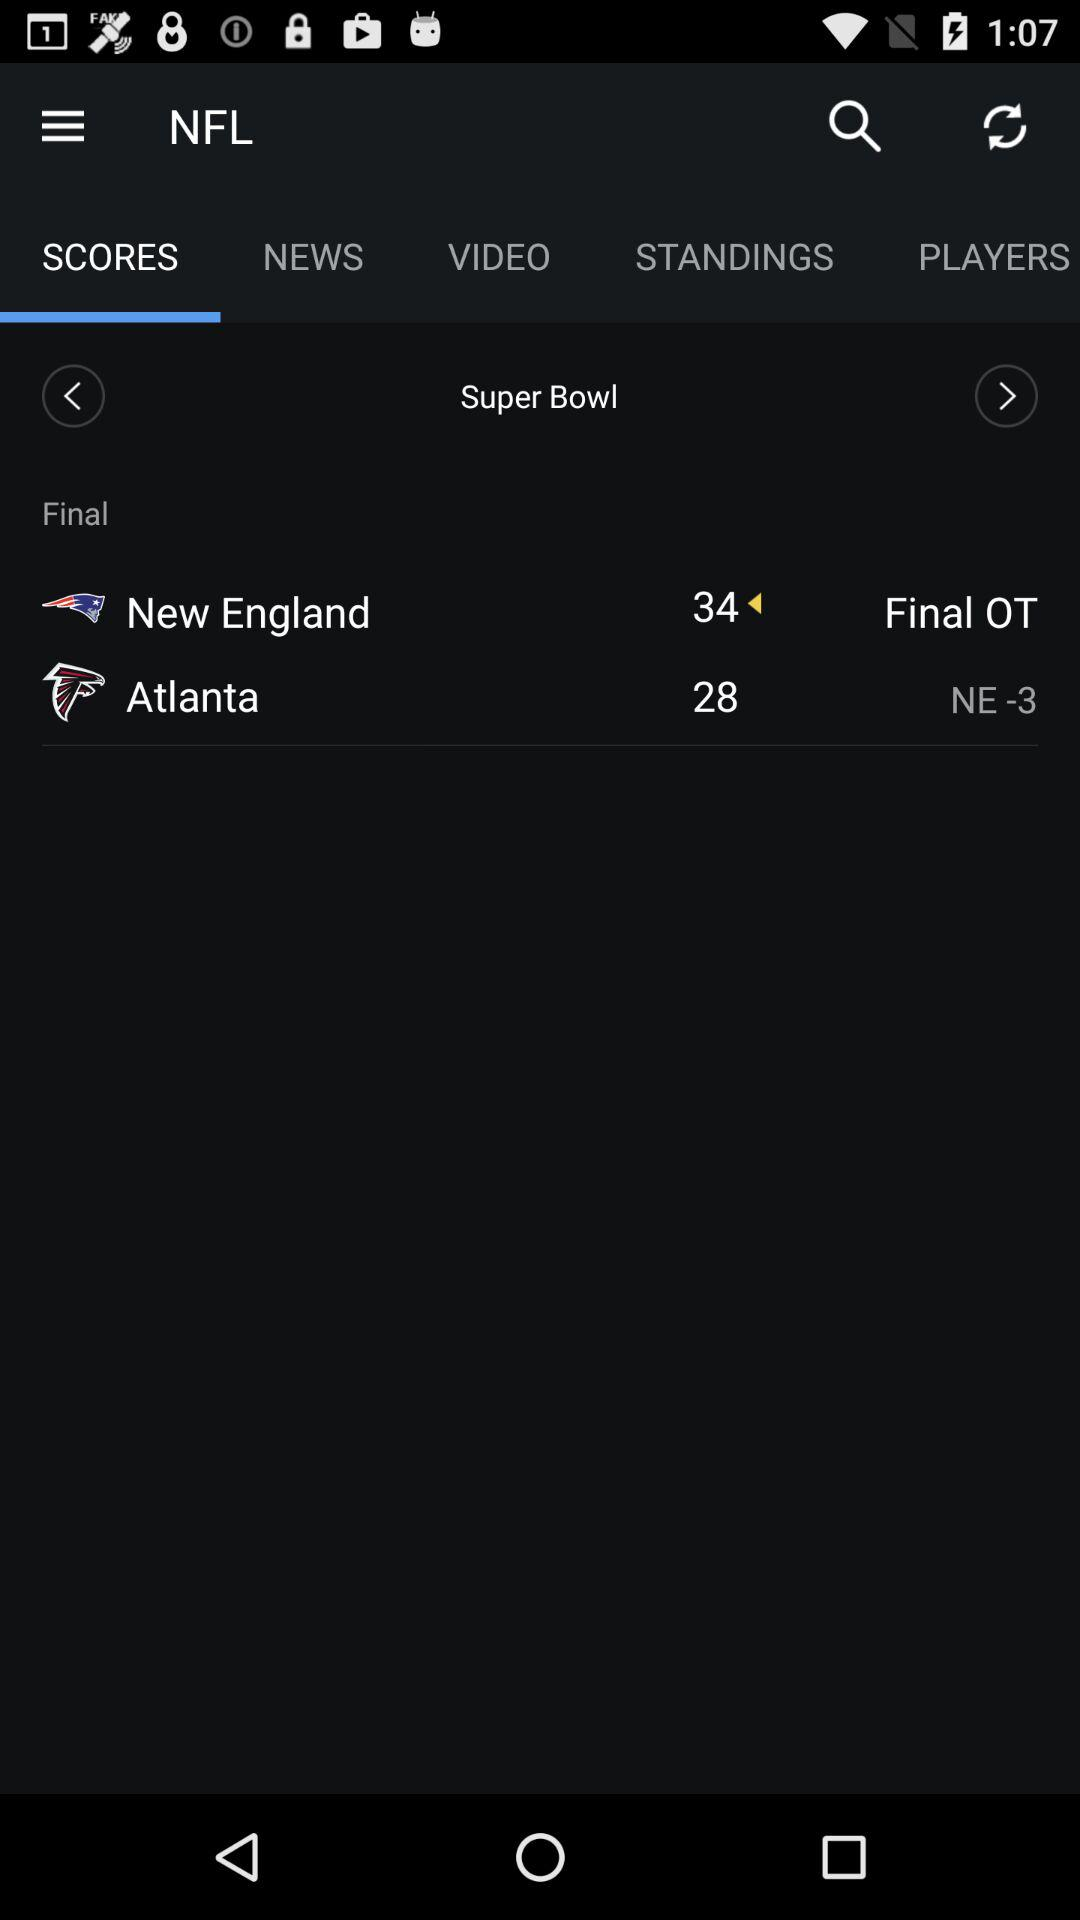What is the name of the game? The name of the game is the NFL. 